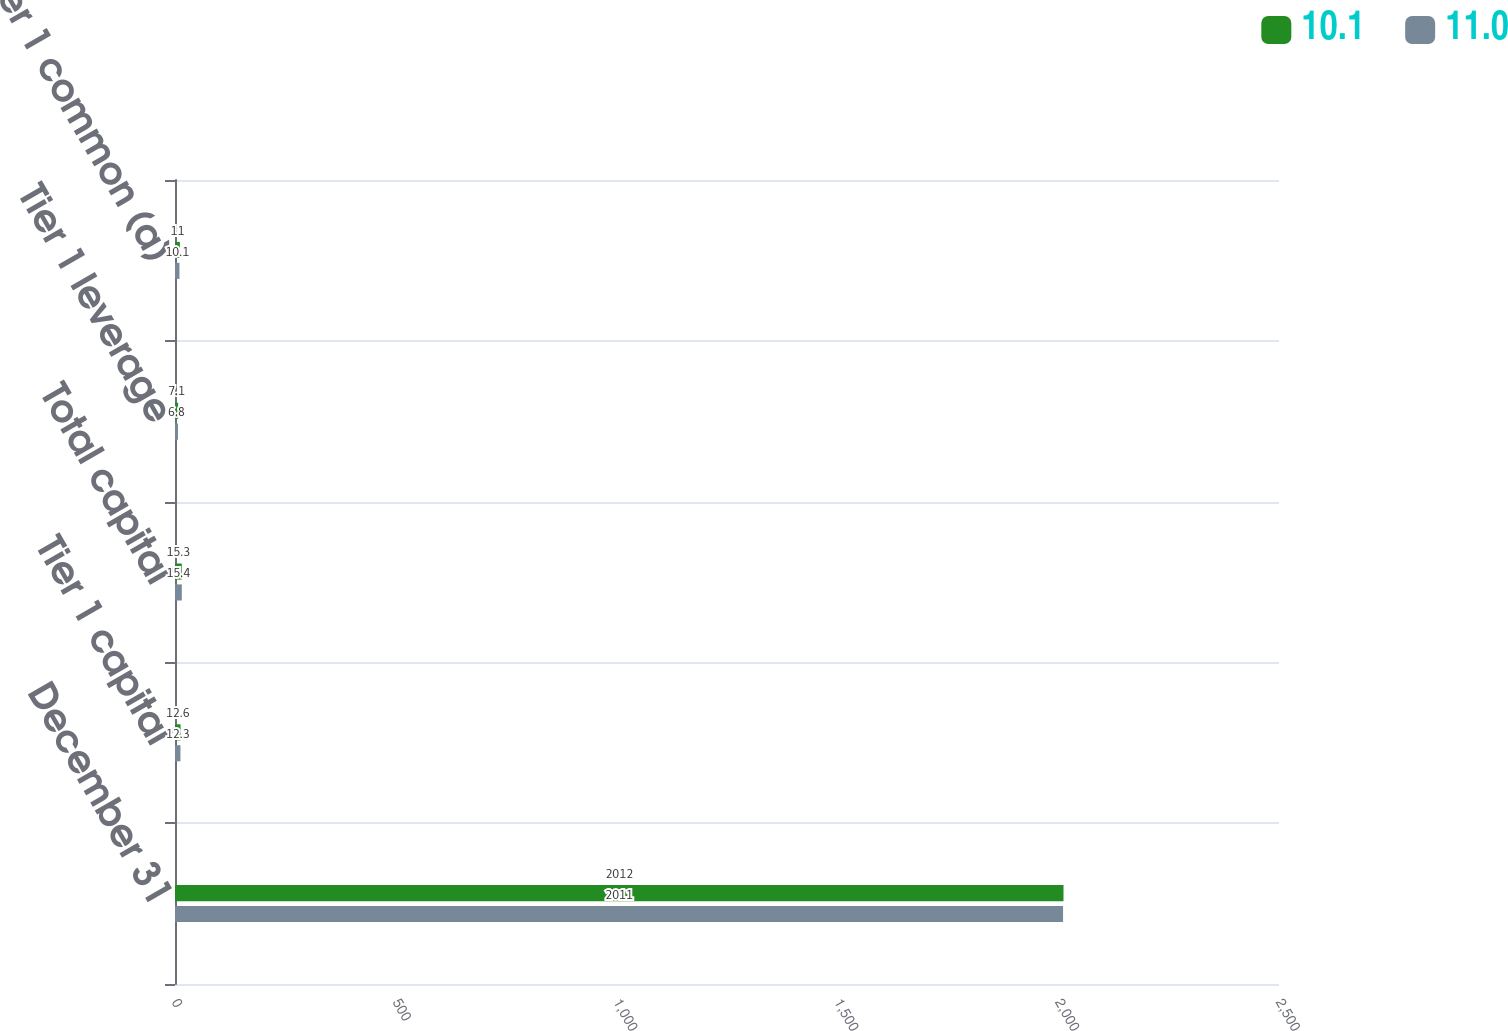Convert chart. <chart><loc_0><loc_0><loc_500><loc_500><stacked_bar_chart><ecel><fcel>December 31<fcel>Tier 1 capital<fcel>Total capital<fcel>Tier 1 leverage<fcel>Tier 1 common (a)<nl><fcel>10.1<fcel>2012<fcel>12.6<fcel>15.3<fcel>7.1<fcel>11<nl><fcel>11<fcel>2011<fcel>12.3<fcel>15.4<fcel>6.8<fcel>10.1<nl></chart> 